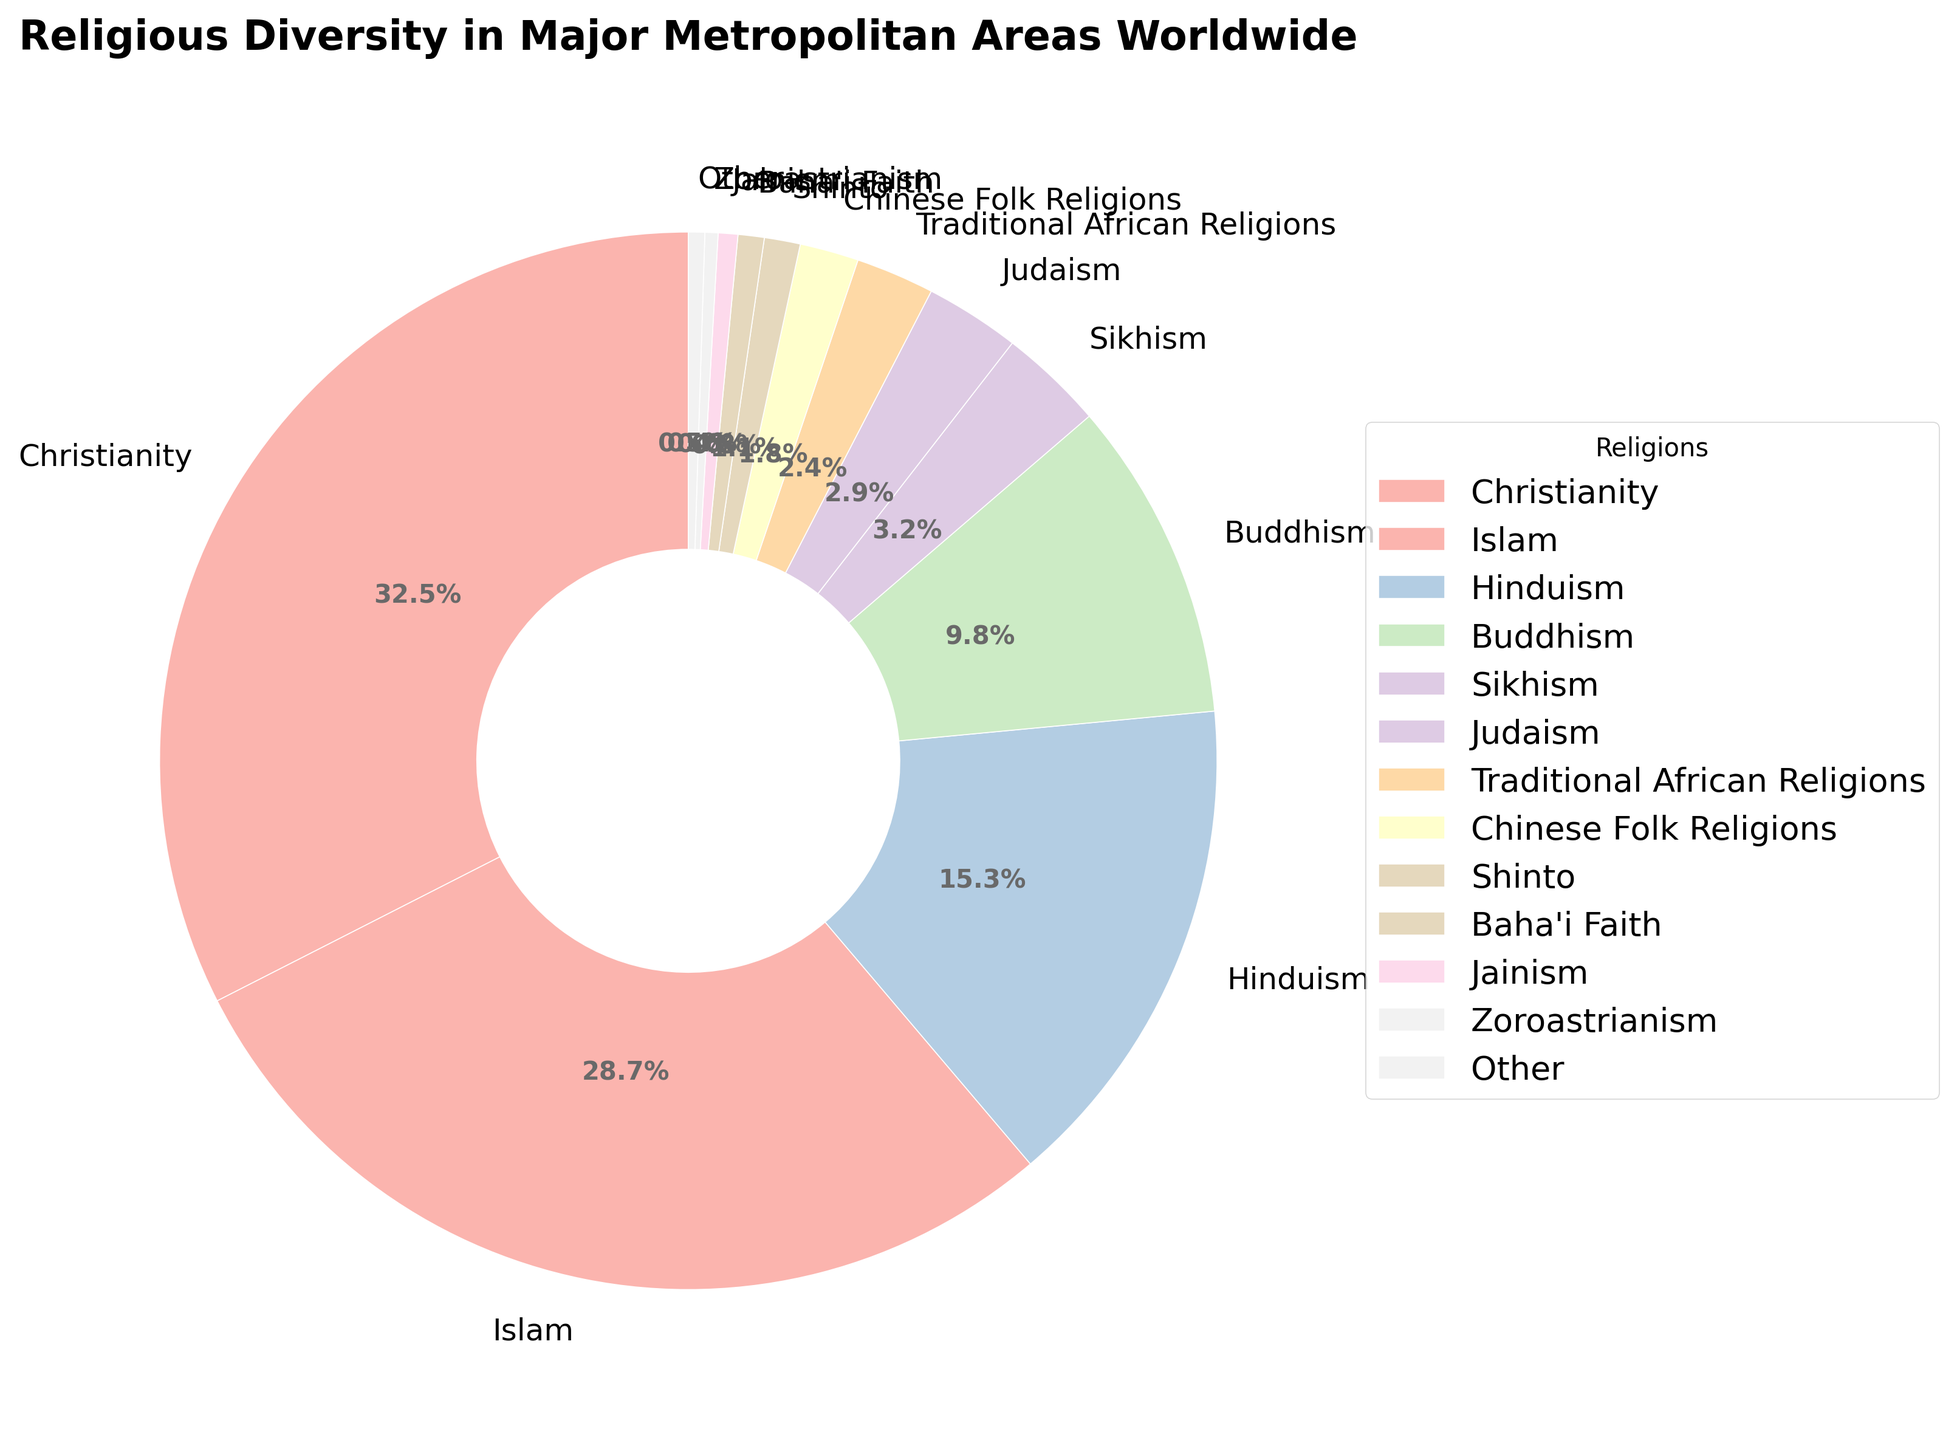What's the percentage of Christianity in major metropolitan areas worldwide? Christianity is labeled with its percentage directly in the pie chart.
Answer: 32.5% Which religions have a percentage less than 5%? Observing the chart, we see slices corresponding to religions with percentages less than 5%: Sikhism, Judaism, Traditional African Religions, Chinese Folk Religions, Shinto, Baha'i Faith, Jainism, Zoroastrianism, and Other.
Answer: Sikhism, Judaism, Traditional African Religions, Chinese Folk Religions, Shinto, Baha'i Faith, Jainism, Zoroastrianism, Other How much greater is the percentage of Christianity compared to Hinduism? The percentage of Christianity is 32.5%, while for Hinduism it is 15.3%. Subtracting these values gives 32.5 - 15.3.
Answer: 17.2% What is the combined percentage of Islam and Buddhism? The chart shows that Islam is 28.7% and Buddhism is 9.8%. Adding these two percentages gives 28.7 + 9.8.
Answer: 38.5% Which religion has the smallest representation, and what is its percentage? The smallest slice in the pie chart corresponds to Zoroastrianism with a percentage of 0.4%.
Answer: Zoroastrianism, 0.4% Compare the percentage of Sikhism to Judaism. Which one is higher and by how much? Sikhism is 3.2% and Judaism is 2.9%. Subtracting these values gives 3.2 - 2.9, and Sikhism is higher.
Answer: Sikhism is higher by 0.3% If we sum the percentages of Christianity, Islam, and Hinduism, what is the total percentage? Christianity is 32.5%, Islam is 28.7%, and Hinduism is 15.3%. Adding these gives 32.5 + 28.7 + 15.3.
Answer: 76.5% What percentage of religions come under 'Other'? The chart shows an 'Other' category with a percentage of 0.5%.
Answer: 0.5% Compare the visual sizes of Buddhism and Shinto on the chart. Which religion appears to have a larger representation, and how can you tell? Buddhism's slice occupies a larger area of the chart compared to Shinto, indicating Buddhism has a greater percentage.
Answer: Buddhism is larger What is the total percentage of all non-Abrahamic religions combined? Non-Abrahamic religions in the chart are Hinduism (15.3%), Buddhism (9.8%), Sikhism (3.2%), Traditional African Religions (2.4%), Chinese Folk Religions (1.8%), Shinto (1.1%), Baha'i Faith (0.8%), Jainism (0.6%), Zoroastrianism (0.4%), and Other (0.5%). Adding these gives 15.3 + 9.8 + 3.2 + 2.4 + 1.8 + 1.1 + 0.8 + 0.6 + 0.4 + 0.5.
Answer: 35.9% 